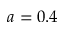Convert formula to latex. <formula><loc_0><loc_0><loc_500><loc_500>a = 0 . 4</formula> 